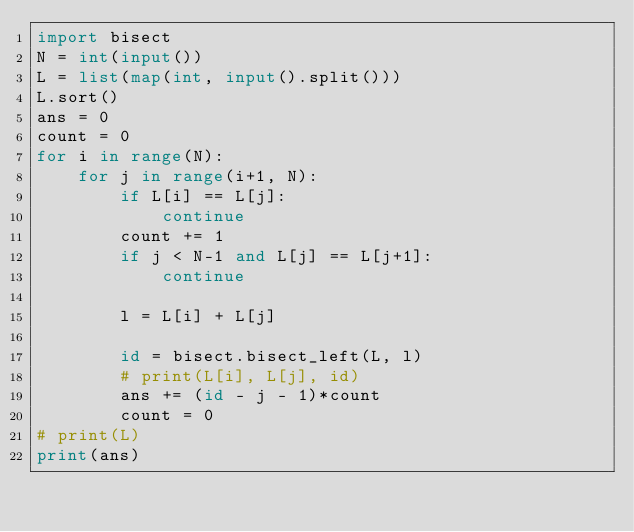Convert code to text. <code><loc_0><loc_0><loc_500><loc_500><_Python_>import bisect
N = int(input())
L = list(map(int, input().split()))
L.sort()
ans = 0
count = 0
for i in range(N):
    for j in range(i+1, N):
        if L[i] == L[j]:
            continue
        count += 1
        if j < N-1 and L[j] == L[j+1]:
            continue

        l = L[i] + L[j]

        id = bisect.bisect_left(L, l)
        # print(L[i], L[j], id)
        ans += (id - j - 1)*count
        count = 0
# print(L)
print(ans)
</code> 